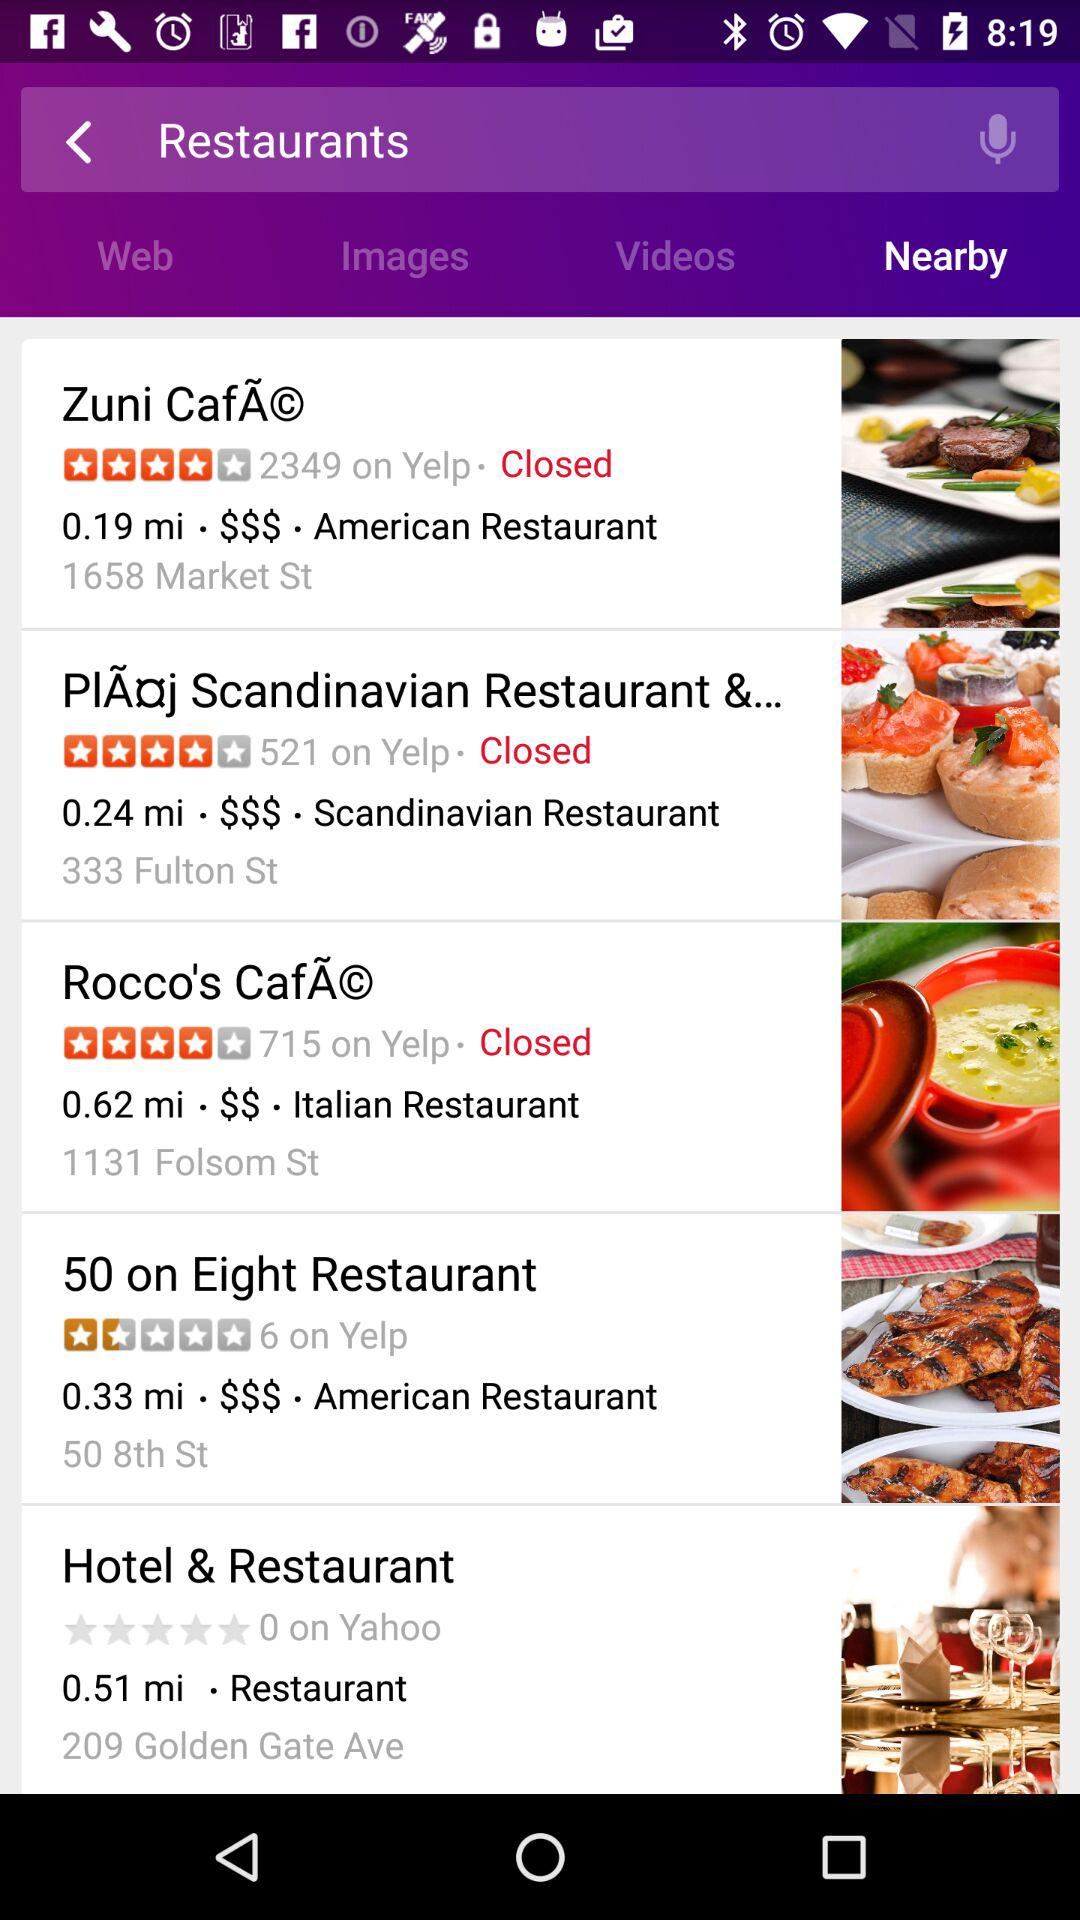How much is "50 on Eight Restaurant" rated on Yelp? The rating on Yelp is 1.5 stars. 